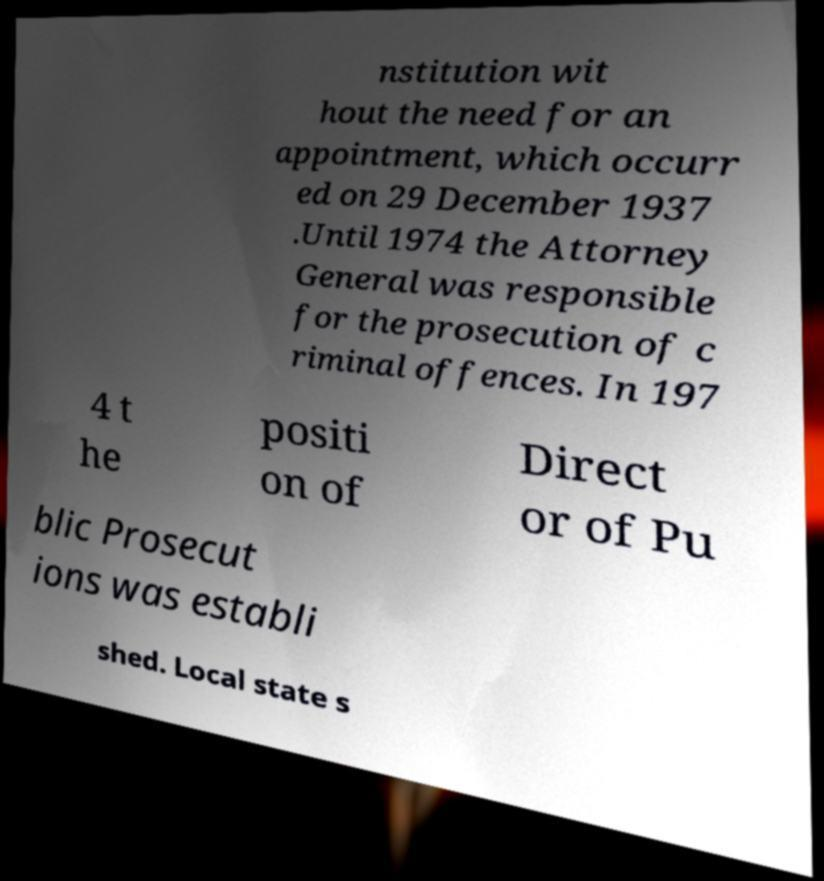Can you accurately transcribe the text from the provided image for me? nstitution wit hout the need for an appointment, which occurr ed on 29 December 1937 .Until 1974 the Attorney General was responsible for the prosecution of c riminal offences. In 197 4 t he positi on of Direct or of Pu blic Prosecut ions was establi shed. Local state s 